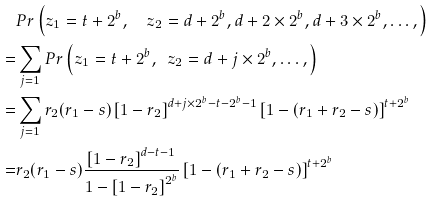Convert formula to latex. <formula><loc_0><loc_0><loc_500><loc_500>& P r \left ( z _ { 1 } = t + 2 ^ { b } , \quad z _ { 2 } = d + 2 ^ { b } , d + 2 \times 2 ^ { b } , d + 3 \times 2 ^ { b } , \dots , \right ) \\ = & \sum _ { j = 1 } P r \left ( z _ { 1 } = t + 2 ^ { b } , \ \ z _ { 2 } = d + j \times 2 ^ { b } , \dots , \right ) \\ = & \sum _ { j = 1 } r _ { 2 } ( r _ { 1 } - s ) \left [ 1 - r _ { 2 } \right ] ^ { d + j \times 2 ^ { b } - t - 2 ^ { b } - 1 } \left [ 1 - ( r _ { 1 } + r _ { 2 } - s ) \right ] ^ { t + 2 ^ { b } } \\ = & r _ { 2 } ( r _ { 1 } - s ) \frac { \left [ 1 - r _ { 2 } \right ] ^ { d - t - 1 } } { 1 - \left [ 1 - r _ { 2 } \right ] ^ { 2 ^ { b } } } \left [ 1 - ( r _ { 1 } + r _ { 2 } - s ) \right ] ^ { t + 2 ^ { b } }</formula> 